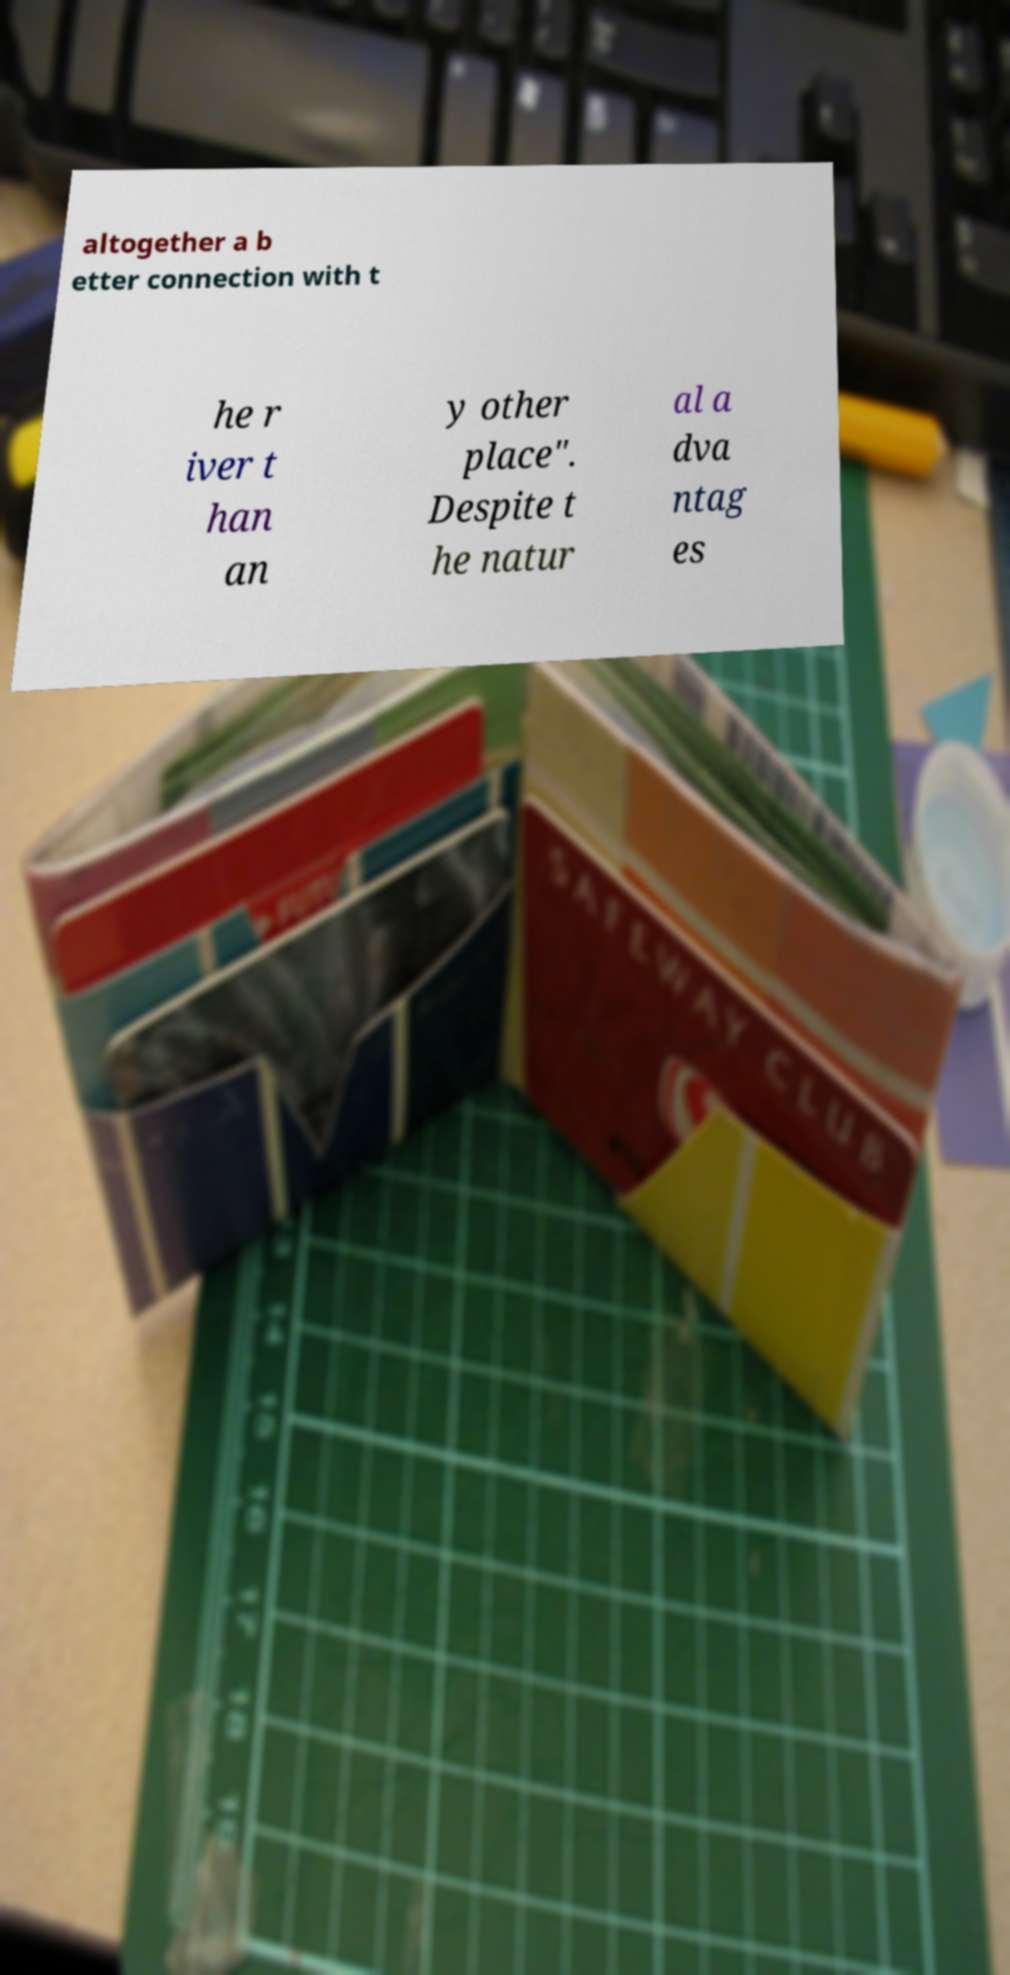Please identify and transcribe the text found in this image. altogether a b etter connection with t he r iver t han an y other place". Despite t he natur al a dva ntag es 